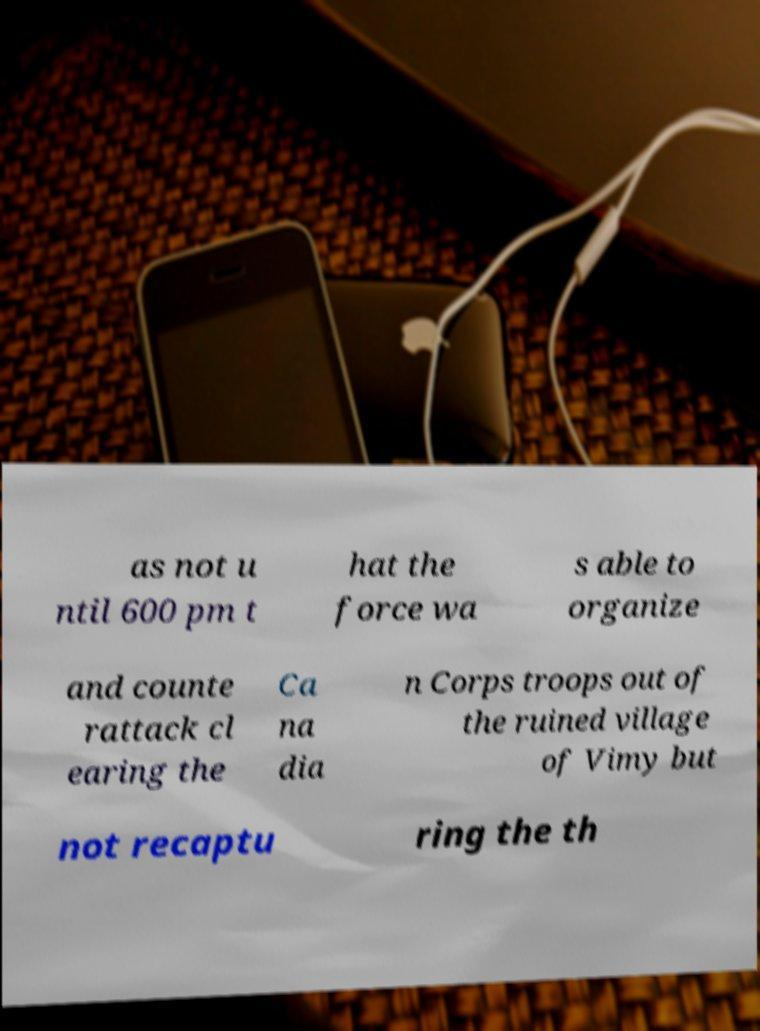Please read and relay the text visible in this image. What does it say? as not u ntil 600 pm t hat the force wa s able to organize and counte rattack cl earing the Ca na dia n Corps troops out of the ruined village of Vimy but not recaptu ring the th 